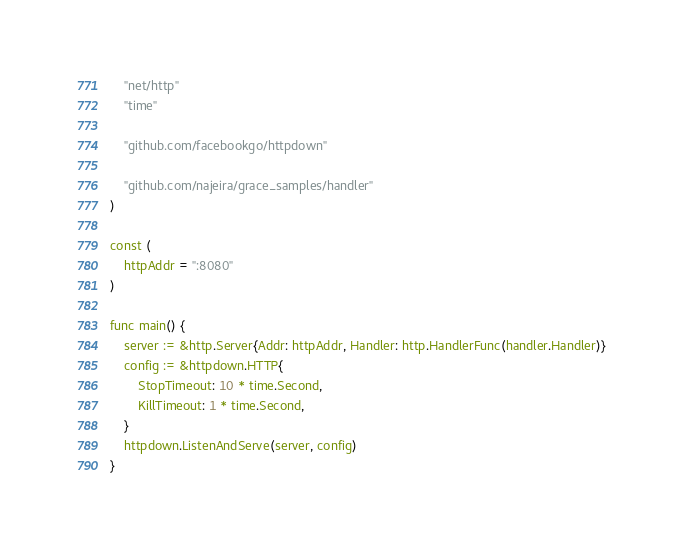<code> <loc_0><loc_0><loc_500><loc_500><_Go_>	"net/http"
	"time"

	"github.com/facebookgo/httpdown"

	"github.com/najeira/grace_samples/handler"
)

const (
	httpAddr = ":8080"
)

func main() {
	server := &http.Server{Addr: httpAddr, Handler: http.HandlerFunc(handler.Handler)}
	config := &httpdown.HTTP{
		StopTimeout: 10 * time.Second,
		KillTimeout: 1 * time.Second,
	}
	httpdown.ListenAndServe(server, config)
}
</code> 